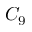<formula> <loc_0><loc_0><loc_500><loc_500>C _ { 9 }</formula> 